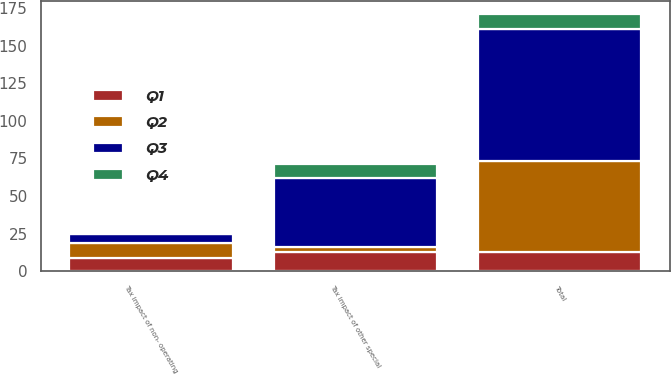Convert chart to OTSL. <chart><loc_0><loc_0><loc_500><loc_500><stacked_bar_chart><ecel><fcel>Tax impact of other special<fcel>Tax impact of non- operating<fcel>Total<nl><fcel>Q4<fcel>9<fcel>1<fcel>10<nl><fcel>Q1<fcel>13<fcel>9<fcel>13<nl><fcel>Q3<fcel>46<fcel>6<fcel>88<nl><fcel>Q2<fcel>3<fcel>10<fcel>60<nl></chart> 